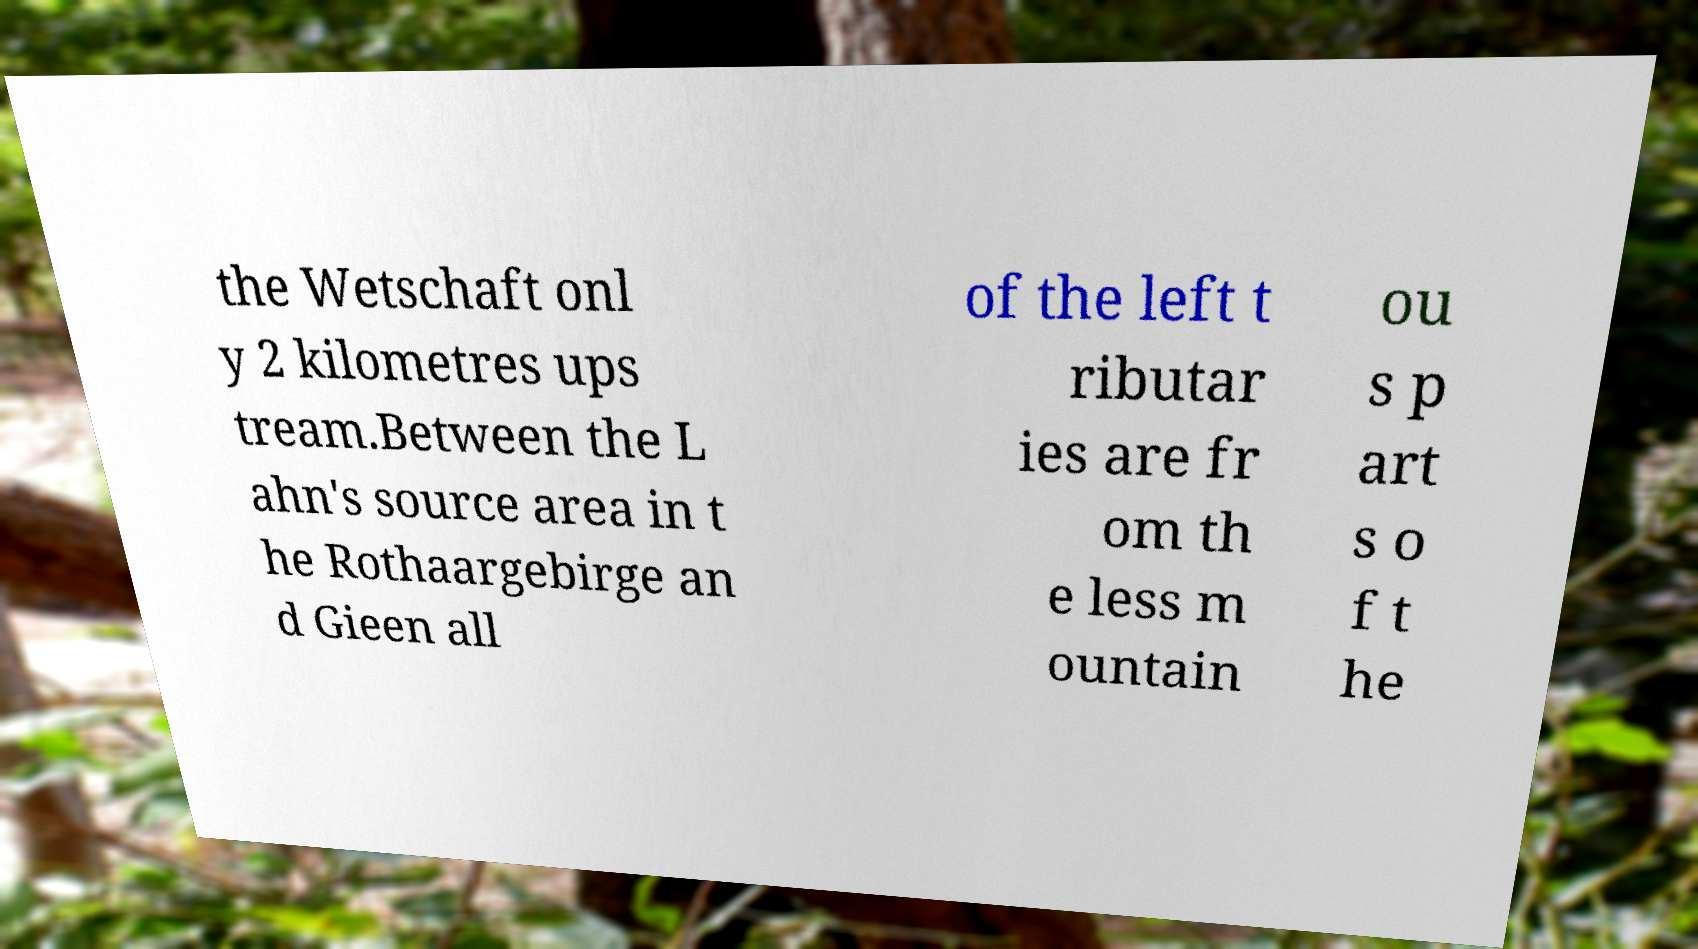Could you assist in decoding the text presented in this image and type it out clearly? the Wetschaft onl y 2 kilometres ups tream.Between the L ahn's source area in t he Rothaargebirge an d Gieen all of the left t ributar ies are fr om th e less m ountain ou s p art s o f t he 